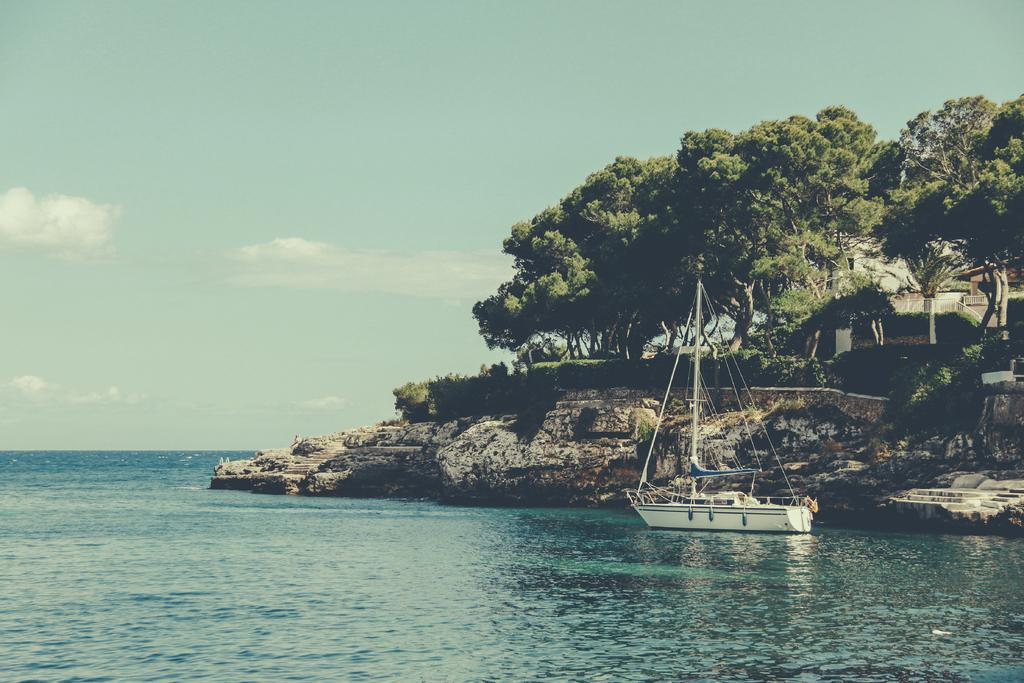What is the main subject of the image? The main subject of the image is a boat. What is the boat doing in the image? The boat is floating on the water. What can be seen in the background of the image? In the background of the image, there are rock hills, trees, a house, stairs, and the sky. What is the condition of the sky in the image? The sky is visible in the background of the image, and there are clouds present. What type of pail is being used to collect water from the river in the image? There is no river or pail present in the image; it features a boat floating on the water with a background that includes rock hills, trees, a house, stairs, and the sky. 